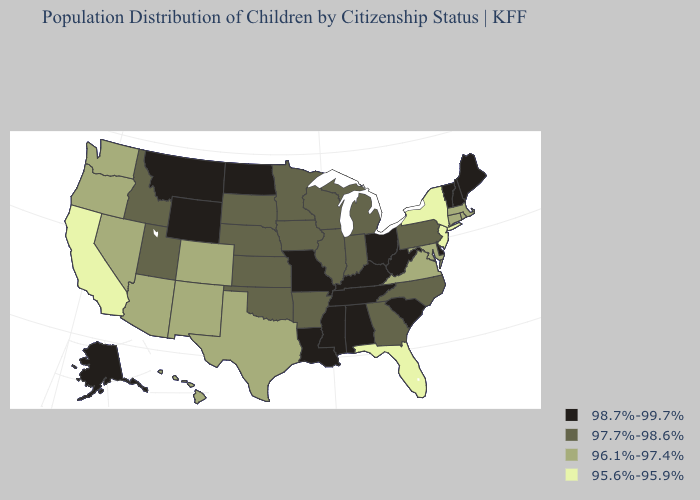Does Ohio have the lowest value in the MidWest?
Give a very brief answer. No. Does New Mexico have the lowest value in the West?
Keep it brief. No. What is the value of Rhode Island?
Keep it brief. 96.1%-97.4%. What is the highest value in states that border Idaho?
Be succinct. 98.7%-99.7%. Which states have the lowest value in the Northeast?
Be succinct. New Jersey, New York. What is the value of California?
Write a very short answer. 95.6%-95.9%. Name the states that have a value in the range 96.1%-97.4%?
Keep it brief. Arizona, Colorado, Connecticut, Hawaii, Maryland, Massachusetts, Nevada, New Mexico, Oregon, Rhode Island, Texas, Virginia, Washington. Among the states that border Arizona , which have the lowest value?
Answer briefly. California. Which states hav the highest value in the South?
Be succinct. Alabama, Delaware, Kentucky, Louisiana, Mississippi, South Carolina, Tennessee, West Virginia. What is the highest value in the USA?
Write a very short answer. 98.7%-99.7%. Which states have the lowest value in the West?
Concise answer only. California. What is the value of Pennsylvania?
Be succinct. 97.7%-98.6%. What is the highest value in the West ?
Concise answer only. 98.7%-99.7%. Does New York have the highest value in the USA?
Keep it brief. No. What is the highest value in the MidWest ?
Concise answer only. 98.7%-99.7%. 